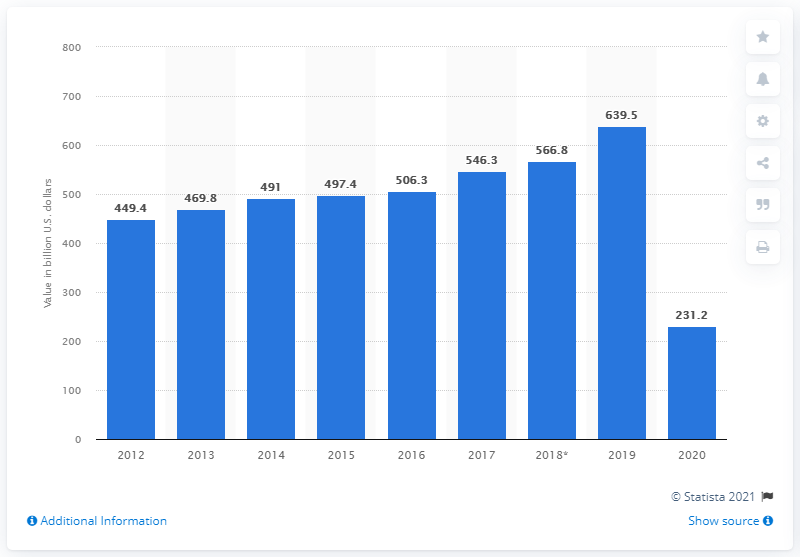List a handful of essential elements in this visual. In 2020, the amount of inbound tourism spending in Europe was 231.2 billion U.S. dollars. 